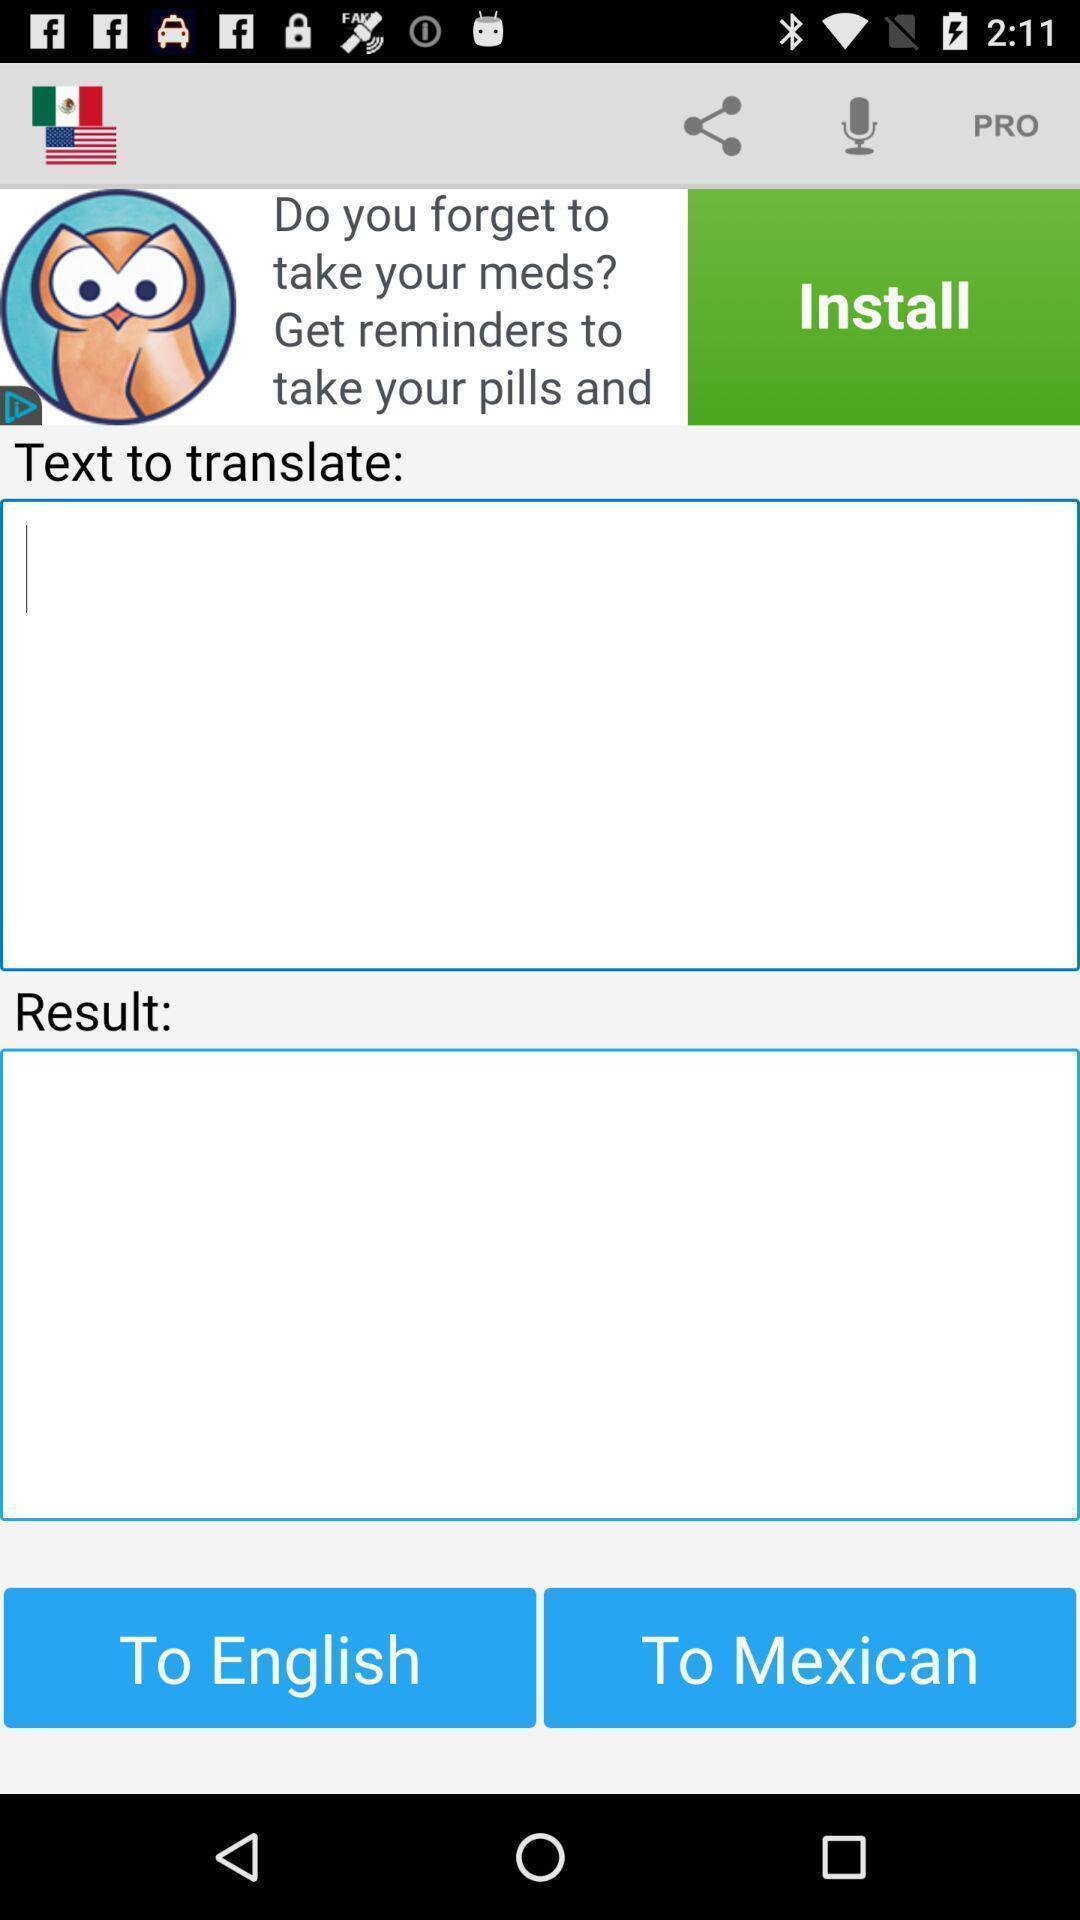Tell me what you see in this picture. Screen displaying the page to translate. 